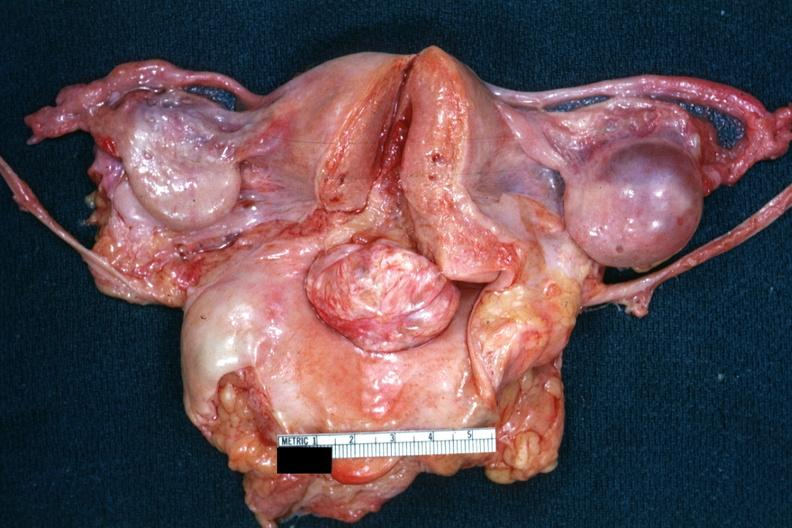what is opened uterus and cervix with large cervical myoma protruding into vagina slide surface of this myoma?
Answer the question using a single word or phrase. Close-up cut 